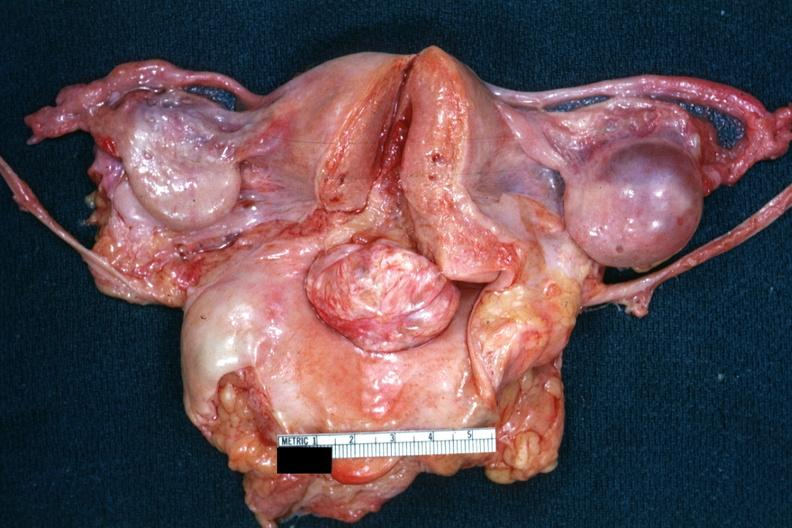what is opened uterus and cervix with large cervical myoma protruding into vagina slide surface of this myoma?
Answer the question using a single word or phrase. Close-up cut 